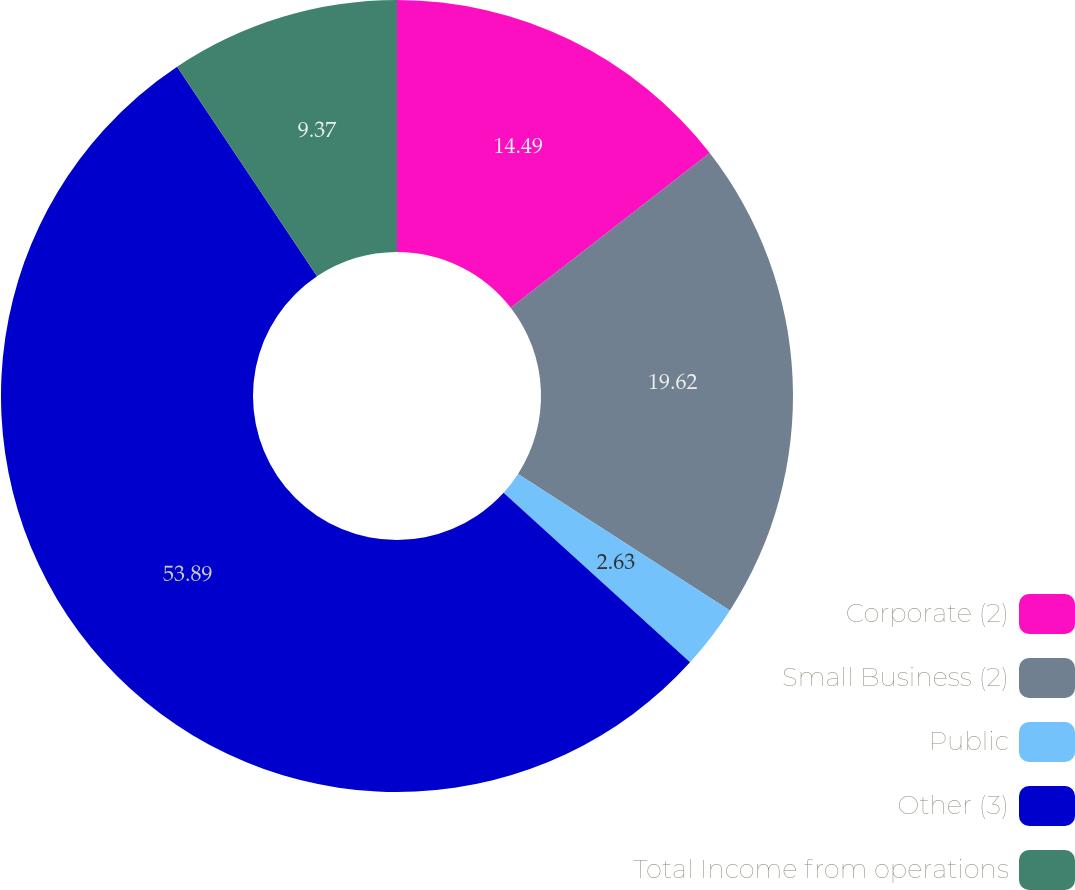Convert chart. <chart><loc_0><loc_0><loc_500><loc_500><pie_chart><fcel>Corporate (2)<fcel>Small Business (2)<fcel>Public<fcel>Other (3)<fcel>Total Income from operations<nl><fcel>14.49%<fcel>19.62%<fcel>2.63%<fcel>53.89%<fcel>9.37%<nl></chart> 